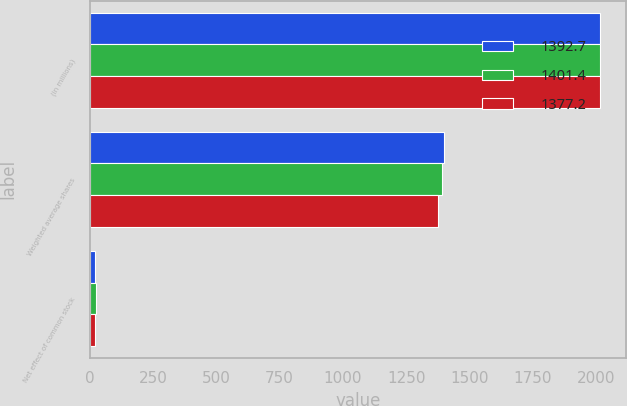<chart> <loc_0><loc_0><loc_500><loc_500><stacked_bar_chart><ecel><fcel>(in millions)<fcel>Weighted average shares<fcel>Net effect of common stock<nl><fcel>1392.7<fcel>2018<fcel>1401.4<fcel>20.4<nl><fcel>1401.4<fcel>2017<fcel>1392.7<fcel>22.6<nl><fcel>1377.2<fcel>2016<fcel>1377.2<fcel>19.6<nl></chart> 